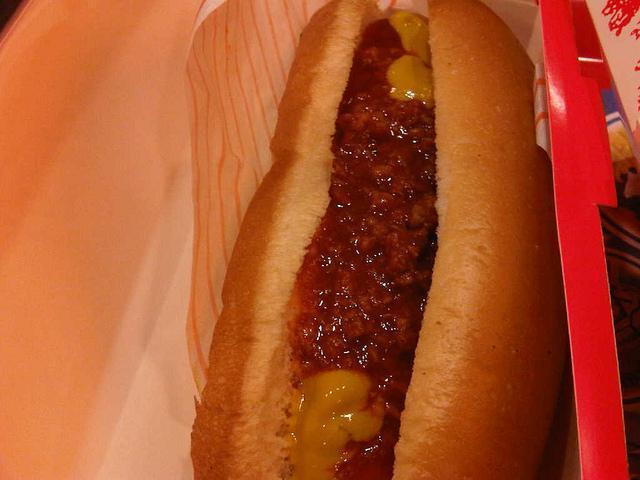How many hot dogs are there?
Give a very brief answer. 1. 